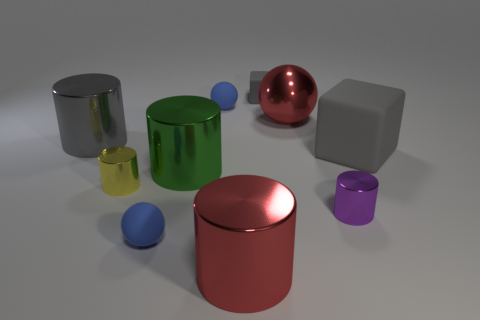Subtract all purple cylinders. How many blue spheres are left? 2 Subtract all metal spheres. How many spheres are left? 2 Subtract all green cylinders. How many cylinders are left? 4 Subtract all gray cylinders. Subtract all yellow blocks. How many cylinders are left? 4 Subtract all cubes. How many objects are left? 8 Add 8 red cylinders. How many red cylinders are left? 9 Add 1 spheres. How many spheres exist? 4 Subtract 1 purple cylinders. How many objects are left? 9 Subtract all big red shiny things. Subtract all red shiny cylinders. How many objects are left? 7 